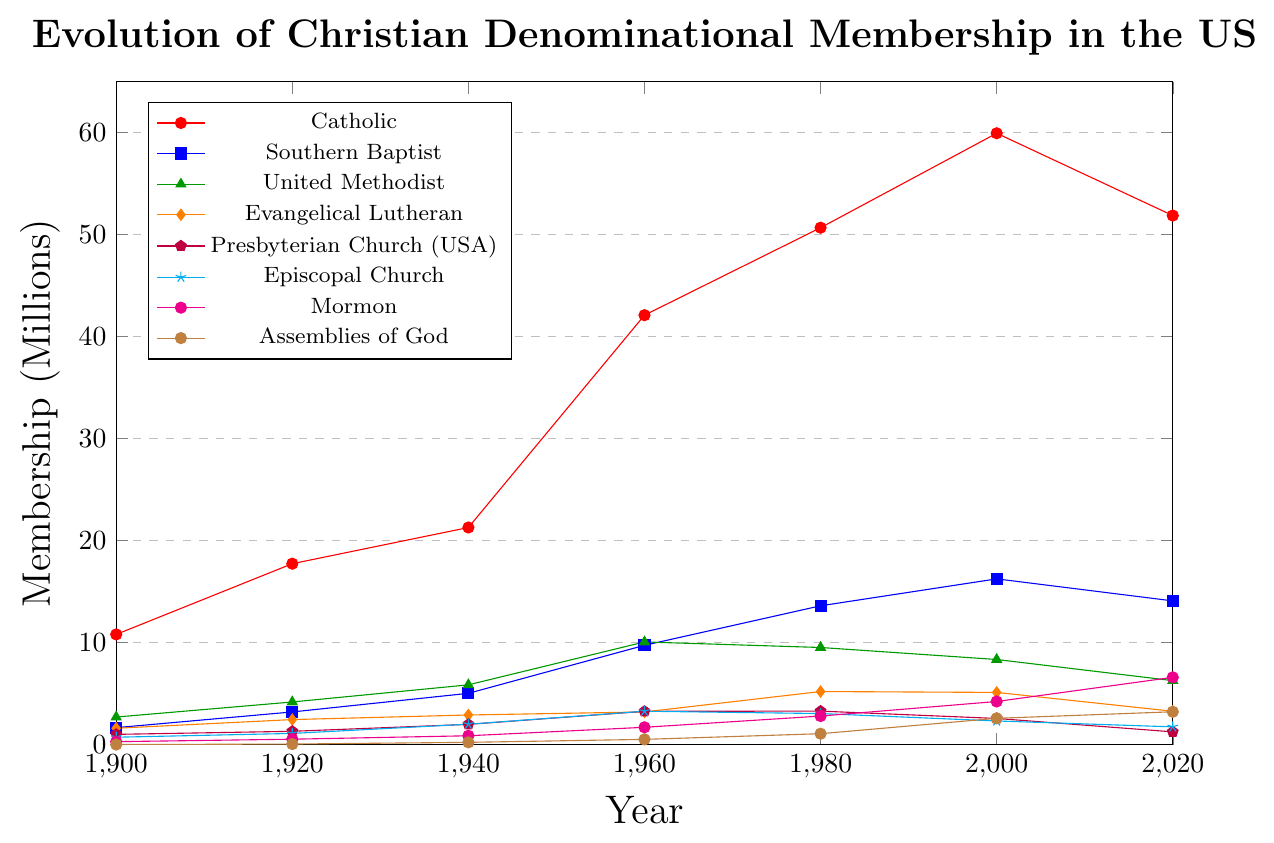Which denomination had the highest membership in 2020? From the plot, the Catholic denomination has the highest point in 2020, followed by a noticeable gap to other denominations. Hence, Catholics had the highest membership in 2020.
Answer: Catholics What is the difference in membership between Catholics and Southern Baptists in 2000? From the plot, the membership of Catholics in 2000 is approximately 59.94 million, and the membership of Southern Baptists is around 16.25 million. Subtracting the two gives 59.94 - 16.25 = 43.69 million.
Answer: 43.69 million How did the membership of the United Methodist Church change between 1940 and 2020? Looking at the plot, in 1940, the United Methodist Church had a membership of around 5.86 million, and in 2020, it had around 6.27 million. The change is calculated as 6.27 - 5.86 = 0.41 million increase.
Answer: 0.41 million Which denomination had the most rapid increase in membership between 1900 and 2000? By visually analyzing the slopes of the lines from 1900 to 2000, the Catholic denomination's line has the steepest upward slope, indicating the most rapid increase in membership.
Answer: Catholics In 2020, which denomination had more members: Evangelical Lutheran or Assemblies of God? From the plotted data, Evangelical Lutheran membership in 2020 is around 3.27 million, while the Assemblies of God membership is approximately 3.21 million. Evangelical Lutheran had slightly more members.
Answer: Evangelical Lutheran What is the average membership of the Mormon Church across all recorded years? Summing the Mormon membership numbers: 0.284 + 0.526 + 0.863 + 1.693 + 2.795 + 4.224 + 6.592 gives close to 16.977. Dividing by 7 (the number of recorded years) gives the average ≈ 2.43 million.
Answer: 2.43 million How does the membership trend of the Presbyterian Church (USA) compare from 1960 to 2020? The Presbyterian Church (USA) had a membership of approximately 3.26 million in 1960 and about 1.24 million in 2020, showing a clear declining trend over these years.
Answer: Declining Which denomination shows a membership decline after 2000? Examining the trends from 2000 to 2020, denominations like Catholics, Southern Baptists, United Methodists, Evangelical Lutheran, and Presbyterians show a noticeable decline in membership.
Answer: Multiple denominations (Catholics, Southern Baptists, etc.) What's the combined membership of Episcopal Church and Mormon Church in 1980? In 1980, the Episcopal Church had around 3.041 million members, and the Mormon Church had about 2.795 million members. Adding these gives 3.041 + 2.795 = 5.836 million.
Answer: 5.836 million Has the membership of the Assemblies of God ever surpassed that of the Evangelical Lutheran Church? By examining the graph, from 1960 onwards, the membership of the Assemblies of God rose significantly, and by 2000, it surpassed the membership of the Evangelical Lutheran Church and continues to be higher.
Answer: Yes 